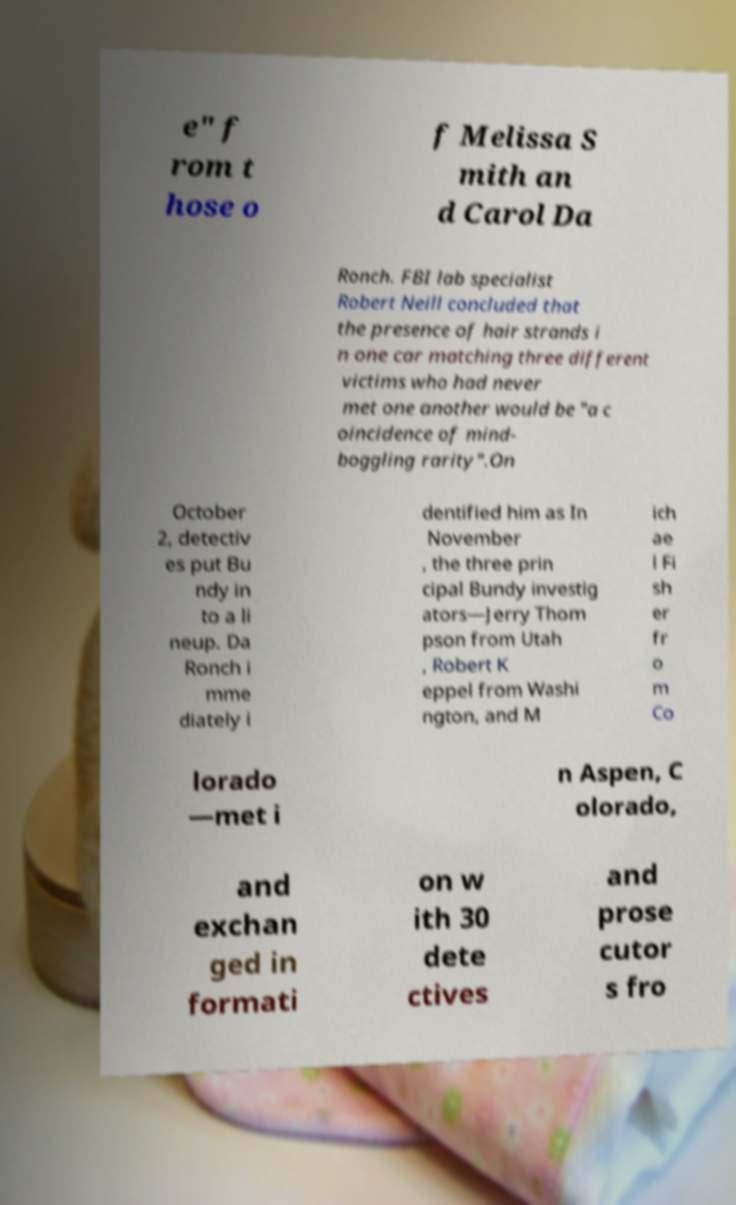I need the written content from this picture converted into text. Can you do that? e" f rom t hose o f Melissa S mith an d Carol Da Ronch. FBI lab specialist Robert Neill concluded that the presence of hair strands i n one car matching three different victims who had never met one another would be "a c oincidence of mind- boggling rarity".On October 2, detectiv es put Bu ndy in to a li neup. Da Ronch i mme diately i dentified him as In November , the three prin cipal Bundy investig ators—Jerry Thom pson from Utah , Robert K eppel from Washi ngton, and M ich ae l Fi sh er fr o m Co lorado —met i n Aspen, C olorado, and exchan ged in formati on w ith 30 dete ctives and prose cutor s fro 